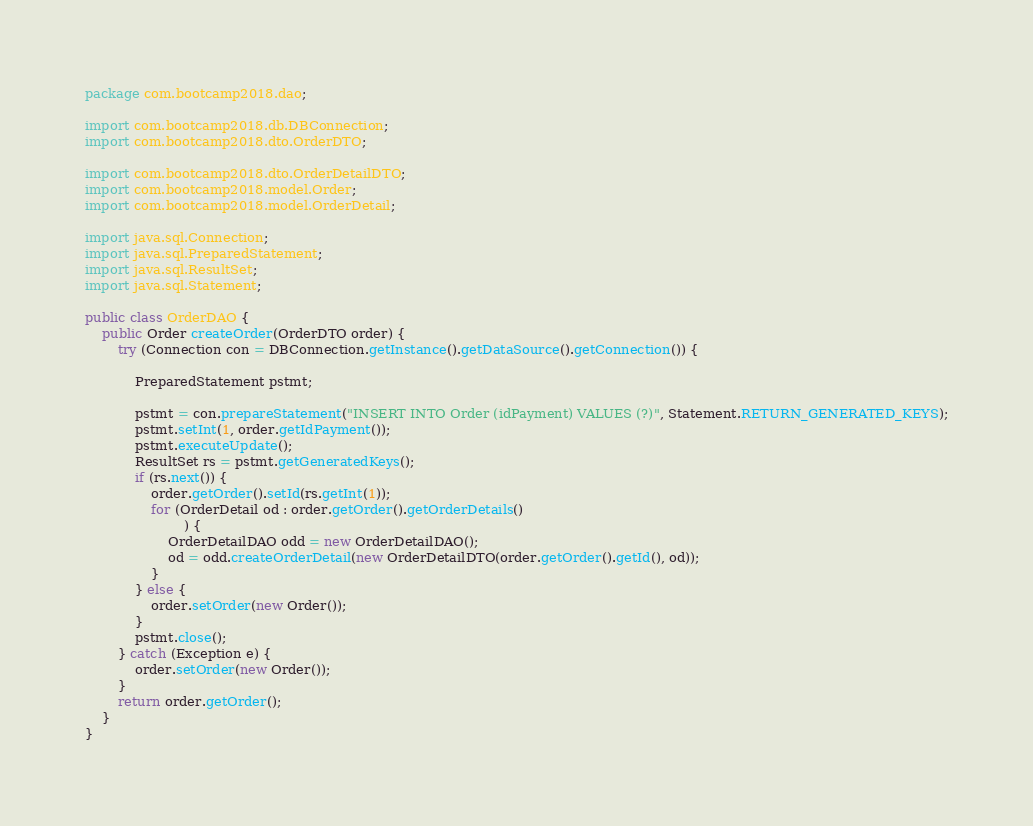Convert code to text. <code><loc_0><loc_0><loc_500><loc_500><_Java_>package com.bootcamp2018.dao;

import com.bootcamp2018.db.DBConnection;
import com.bootcamp2018.dto.OrderDTO;

import com.bootcamp2018.dto.OrderDetailDTO;
import com.bootcamp2018.model.Order;
import com.bootcamp2018.model.OrderDetail;

import java.sql.Connection;
import java.sql.PreparedStatement;
import java.sql.ResultSet;
import java.sql.Statement;

public class OrderDAO {
    public Order createOrder(OrderDTO order) {
        try (Connection con = DBConnection.getInstance().getDataSource().getConnection()) {

            PreparedStatement pstmt;

            pstmt = con.prepareStatement("INSERT INTO Order (idPayment) VALUES (?)", Statement.RETURN_GENERATED_KEYS);
            pstmt.setInt(1, order.getIdPayment());
            pstmt.executeUpdate();
            ResultSet rs = pstmt.getGeneratedKeys();
            if (rs.next()) {
                order.getOrder().setId(rs.getInt(1));
                for (OrderDetail od : order.getOrder().getOrderDetails()
                        ) {
                    OrderDetailDAO odd = new OrderDetailDAO();
                    od = odd.createOrderDetail(new OrderDetailDTO(order.getOrder().getId(), od));
                }
            } else {
                order.setOrder(new Order());
            }
            pstmt.close();
        } catch (Exception e) {
            order.setOrder(new Order());
        }
        return order.getOrder();
    }
}
</code> 